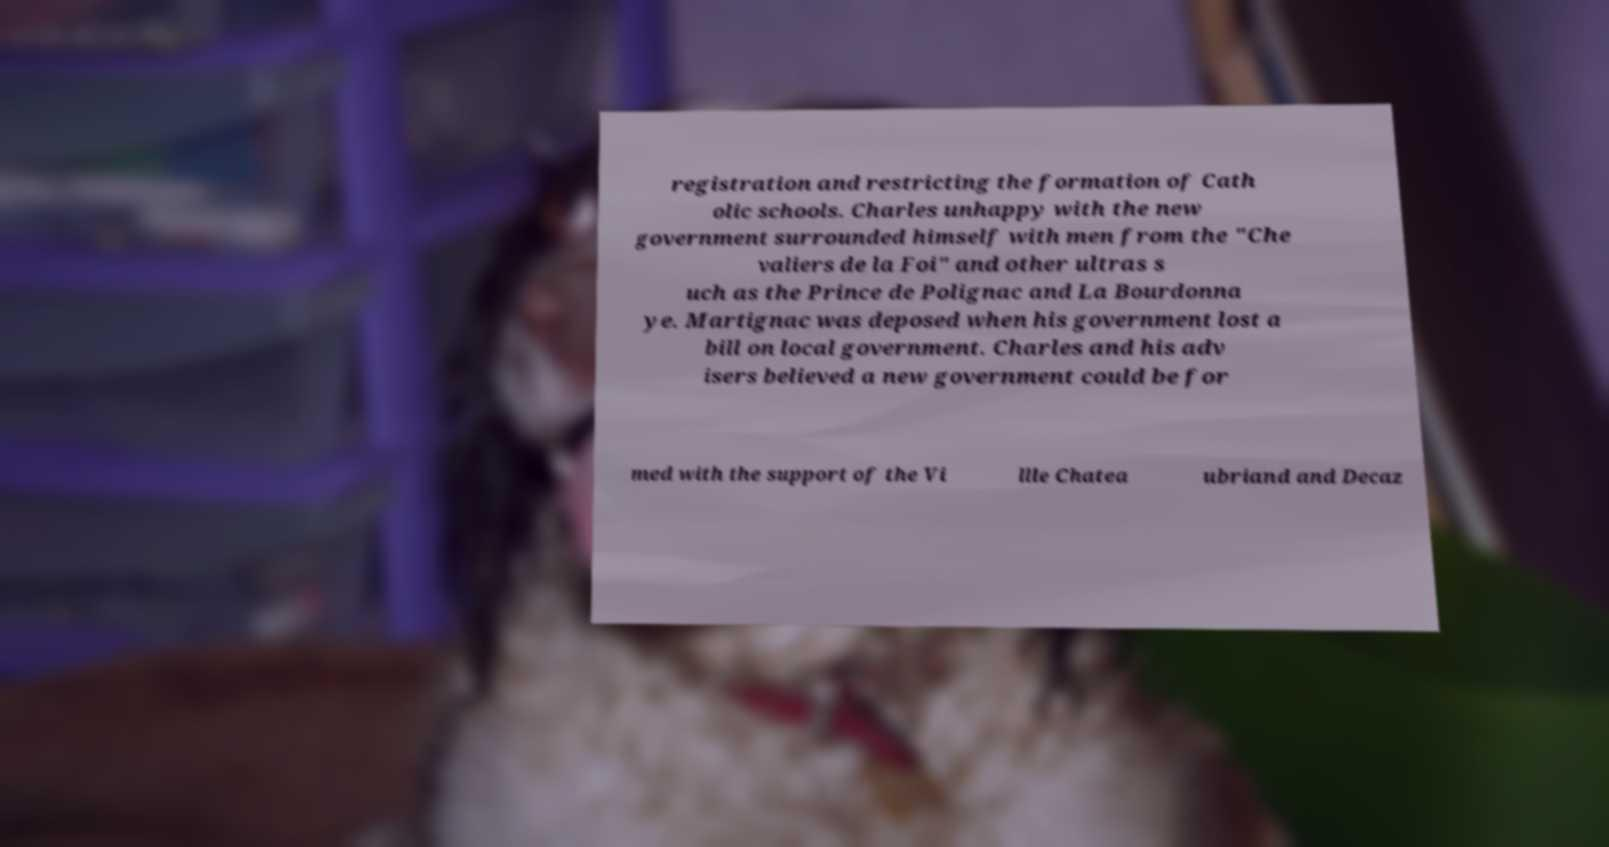For documentation purposes, I need the text within this image transcribed. Could you provide that? registration and restricting the formation of Cath olic schools. Charles unhappy with the new government surrounded himself with men from the "Che valiers de la Foi" and other ultras s uch as the Prince de Polignac and La Bourdonna ye. Martignac was deposed when his government lost a bill on local government. Charles and his adv isers believed a new government could be for med with the support of the Vi llle Chatea ubriand and Decaz 